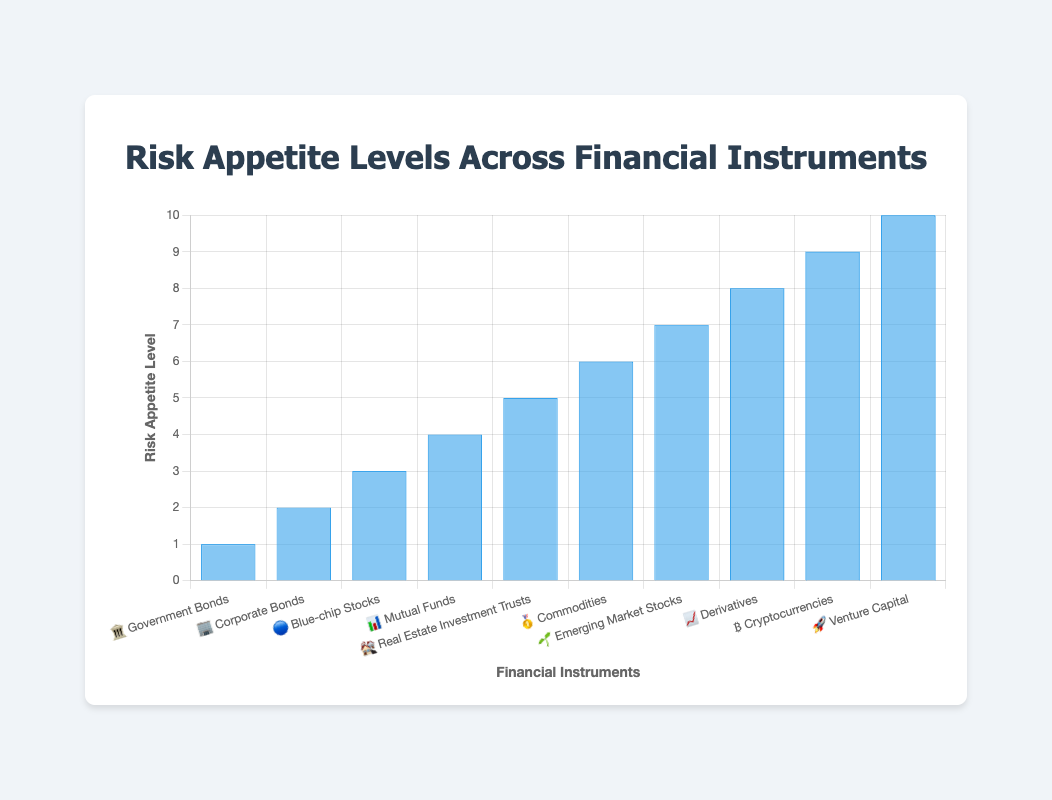What's the title of the chart? The title is shown at the top of the chart, and it is "Risk Appetite Levels Across Financial Instruments".
Answer: Risk Appetite Levels Across Financial Instruments What is the scale of the y-axis? The y-axis shows risk appetite levels which begin at 0 and go up to 10 with a step size of 1.
Answer: 0 to 10 with step size 1 Which financial instrument has the highest risk appetite level? The financial instrument with the highest risk appetite level, marked with a bar reaching the highest point on the y-axis at level 10, is Venture Capital.
Answer: Venture Capital Which financial instrument has the lowest risk appetite level? The financial instrument with the lowest risk appetite level, indicated by a bar reaching the lowest point on the y-axis at level 1, is Government Bonds.
Answer: Government Bonds What is the difference in risk appetite levels between Cryptocurrencies and Government Bonds? Cryptocurrencies have a risk appetite level of 9, while Government Bonds have a level of 1. The difference is 9 - 1 = 8.
Answer: 8 How many financial instruments have a risk appetite level of 6 or higher? The financial instruments with a risk appetite level of 6 or higher are Commodities, Emerging Market Stocks, Derivatives, Cryptocurrencies, and Venture Capital. Counting these gives 5 instruments.
Answer: 5 Which financial instrument is represented by the emoji "🔵"? The emoji "🔵" corresponds to Blue-chip Stocks, as indicated by the labels on the x-axis.
Answer: Blue-chip Stocks Is the risk appetite level for Mutual Funds higher or lower than for Corporate Bonds? Checking the risk appetite levels, Mutual Funds have a level of 4, while Corporate Bonds have a level of 2. This means the risk appetite level for Mutual Funds is higher than that for Corporate Bonds.
Answer: Higher What is the average risk appetite level across all financial instruments? Sum up the risk appetite levels (1 + 2 + 3 + 4 + 5 + 6 + 7 + 8 + 9 + 10) = 55. There are 10 instruments, so the average risk appetite level is 55 / 10 = 5.5.
Answer: 5.5 Which financial instruments have a risk appetite level exactly equal to 7? The financial instrument with a risk appetite level of 7, as shown by the bars reaching the 7 mark on the y-axis, is Emerging Market Stocks.
Answer: Emerging Market Stocks 